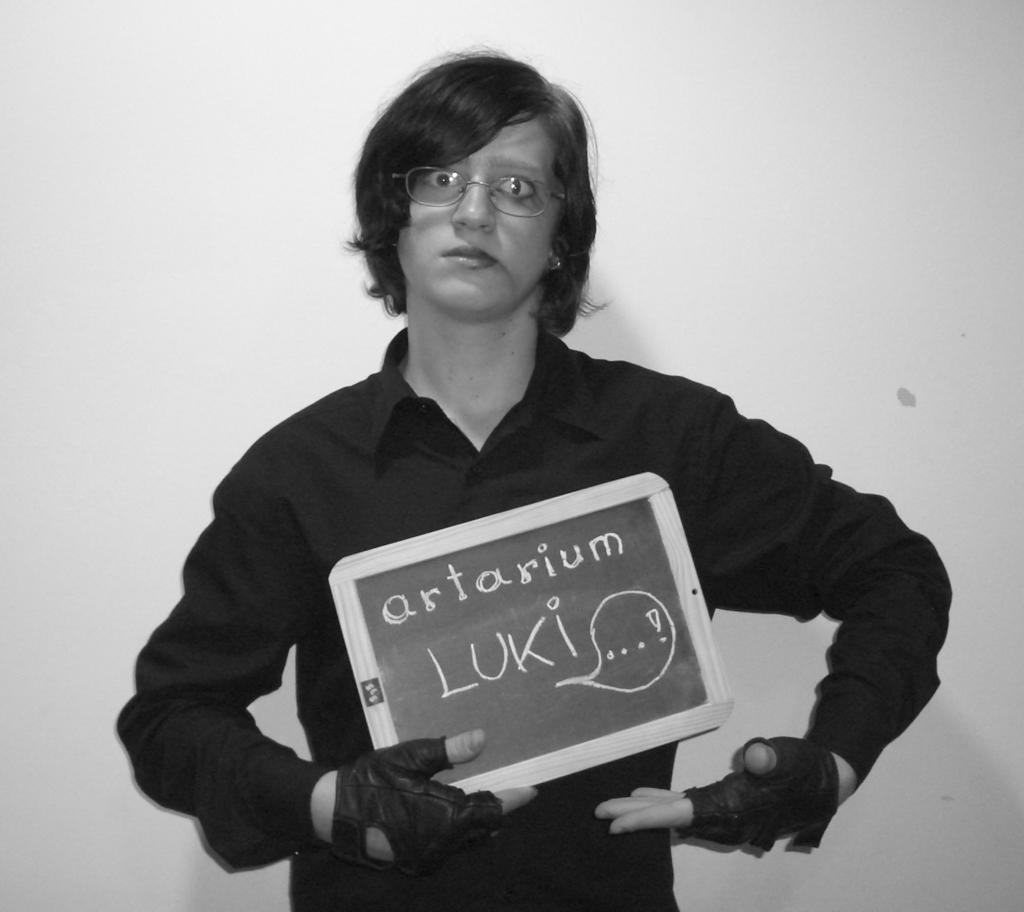What is the main subject of the image? There is a person standing in the image. What is the person holding in the image? The person is holding a slate board. What can be seen in the background of the image? There is a wall in the background of the image. What type of farm animals can be seen in the image? There are no farm animals present in the image. What subject is the person teaching in the image? There is no indication of teaching or a specific subject in the image. 